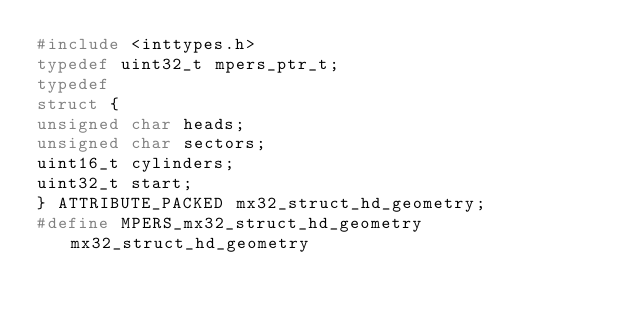<code> <loc_0><loc_0><loc_500><loc_500><_C_>#include <inttypes.h>
typedef uint32_t mpers_ptr_t;
typedef
struct {
unsigned char heads;
unsigned char sectors;
uint16_t cylinders;
uint32_t start;
} ATTRIBUTE_PACKED mx32_struct_hd_geometry;
#define MPERS_mx32_struct_hd_geometry mx32_struct_hd_geometry
</code> 